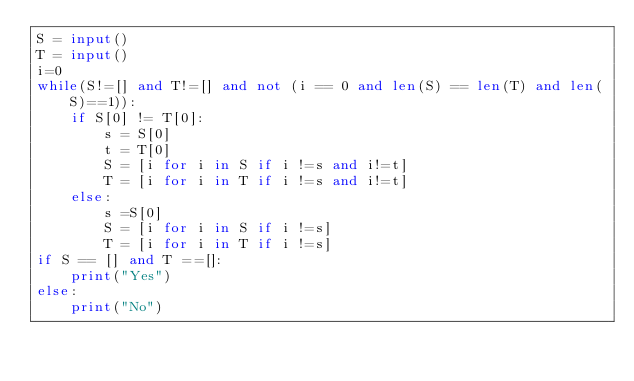<code> <loc_0><loc_0><loc_500><loc_500><_Python_>S = input()
T = input()
i=0
while(S!=[] and T!=[] and not (i == 0 and len(S) == len(T) and len(S)==1)):
    if S[0] != T[0]:
        s = S[0]
        t = T[0]
        S = [i for i in S if i !=s and i!=t]
        T = [i for i in T if i !=s and i!=t]
    else:
        s =S[0]
        S = [i for i in S if i !=s]
        T = [i for i in T if i !=s]
if S == [] and T ==[]:
    print("Yes")
else:
    print("No")</code> 